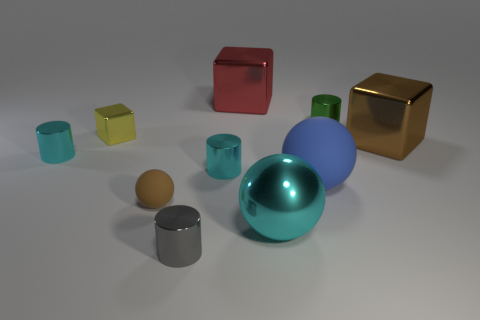How many other objects are there of the same color as the small rubber sphere?
Give a very brief answer. 1. What number of objects are tiny metal cylinders behind the small rubber sphere or large balls?
Offer a very short reply. 5. Does the metal sphere have the same color as the metallic cylinder that is on the left side of the tiny brown sphere?
Give a very brief answer. Yes. What size is the cyan cylinder left of the brown thing to the left of the large matte sphere?
Provide a succinct answer. Small. What number of objects are big red things or objects that are behind the brown metal cube?
Your response must be concise. 3. There is a cyan metal thing in front of the blue sphere; is its shape the same as the small brown object?
Give a very brief answer. Yes. What number of big blue matte objects are behind the blue rubber sphere that is behind the cyan metallic thing that is in front of the small rubber sphere?
Offer a terse response. 0. What number of objects are small gray metal spheres or yellow metallic blocks?
Ensure brevity in your answer.  1. There is a blue object; is its shape the same as the small thing that is in front of the cyan shiny ball?
Ensure brevity in your answer.  No. The big metal object that is to the right of the large cyan sphere has what shape?
Offer a terse response. Cube. 